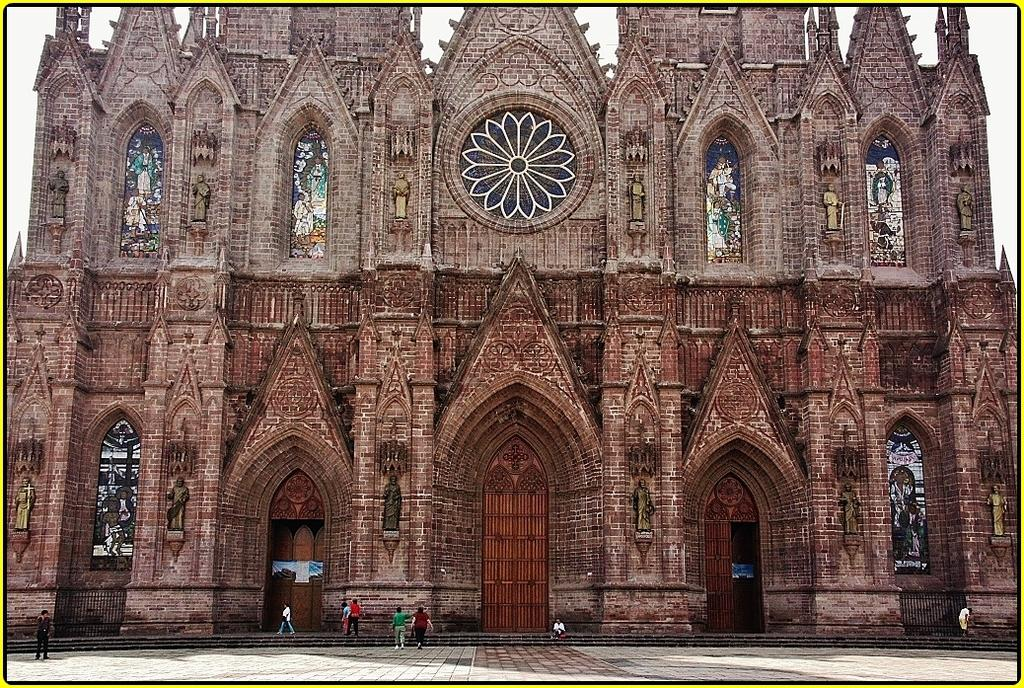What type of structure is present in the image? There is a building in the image. What are the people in the image doing? There are persons sitting and standing on the floor in the image. What can be seen in the background of the image? The sky is visible in the background of the image. What type of chain can be seen connecting the persons in the image? There is no chain present in the image; the persons are not connected by any visible means. 